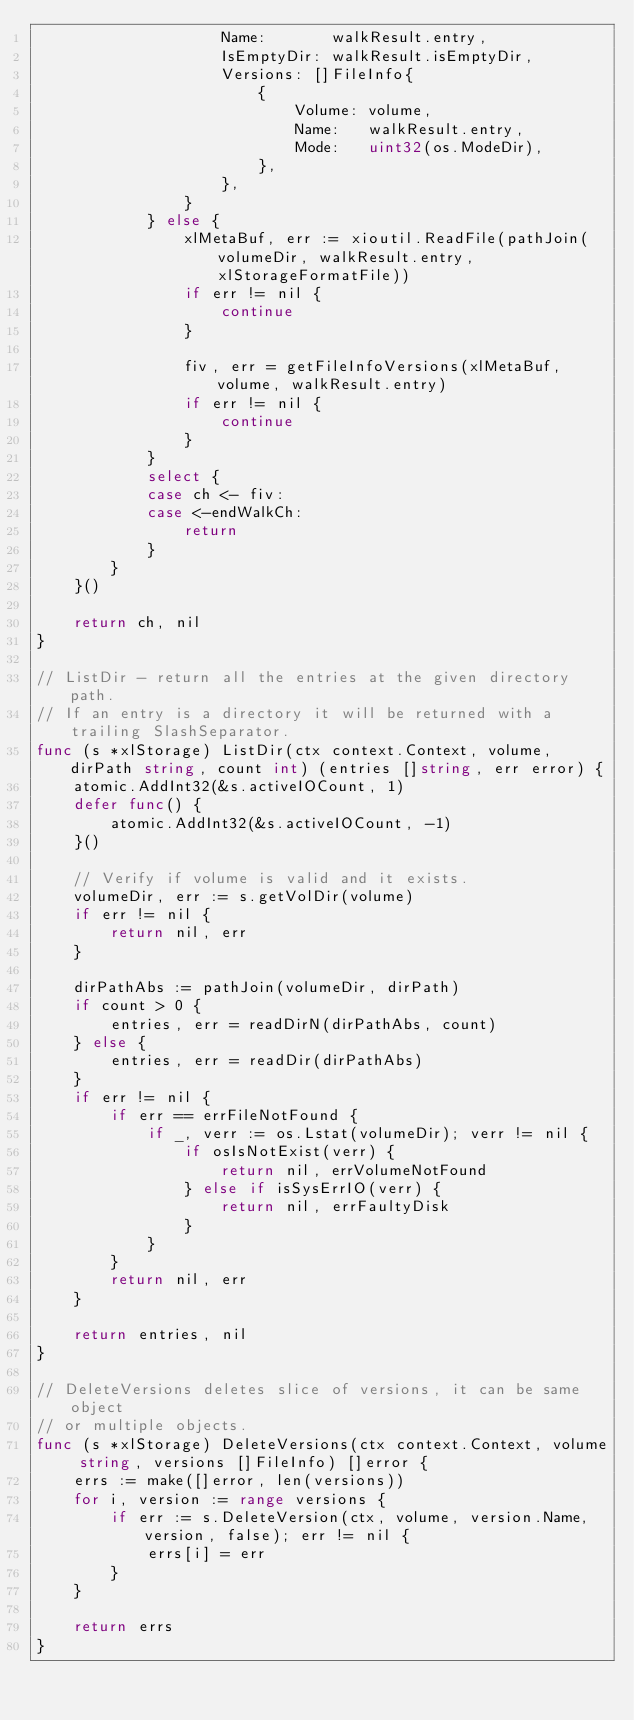<code> <loc_0><loc_0><loc_500><loc_500><_Go_>					Name:       walkResult.entry,
					IsEmptyDir: walkResult.isEmptyDir,
					Versions: []FileInfo{
						{
							Volume: volume,
							Name:   walkResult.entry,
							Mode:   uint32(os.ModeDir),
						},
					},
				}
			} else {
				xlMetaBuf, err := xioutil.ReadFile(pathJoin(volumeDir, walkResult.entry, xlStorageFormatFile))
				if err != nil {
					continue
				}

				fiv, err = getFileInfoVersions(xlMetaBuf, volume, walkResult.entry)
				if err != nil {
					continue
				}
			}
			select {
			case ch <- fiv:
			case <-endWalkCh:
				return
			}
		}
	}()

	return ch, nil
}

// ListDir - return all the entries at the given directory path.
// If an entry is a directory it will be returned with a trailing SlashSeparator.
func (s *xlStorage) ListDir(ctx context.Context, volume, dirPath string, count int) (entries []string, err error) {
	atomic.AddInt32(&s.activeIOCount, 1)
	defer func() {
		atomic.AddInt32(&s.activeIOCount, -1)
	}()

	// Verify if volume is valid and it exists.
	volumeDir, err := s.getVolDir(volume)
	if err != nil {
		return nil, err
	}

	dirPathAbs := pathJoin(volumeDir, dirPath)
	if count > 0 {
		entries, err = readDirN(dirPathAbs, count)
	} else {
		entries, err = readDir(dirPathAbs)
	}
	if err != nil {
		if err == errFileNotFound {
			if _, verr := os.Lstat(volumeDir); verr != nil {
				if osIsNotExist(verr) {
					return nil, errVolumeNotFound
				} else if isSysErrIO(verr) {
					return nil, errFaultyDisk
				}
			}
		}
		return nil, err
	}

	return entries, nil
}

// DeleteVersions deletes slice of versions, it can be same object
// or multiple objects.
func (s *xlStorage) DeleteVersions(ctx context.Context, volume string, versions []FileInfo) []error {
	errs := make([]error, len(versions))
	for i, version := range versions {
		if err := s.DeleteVersion(ctx, volume, version.Name, version, false); err != nil {
			errs[i] = err
		}
	}

	return errs
}
</code> 